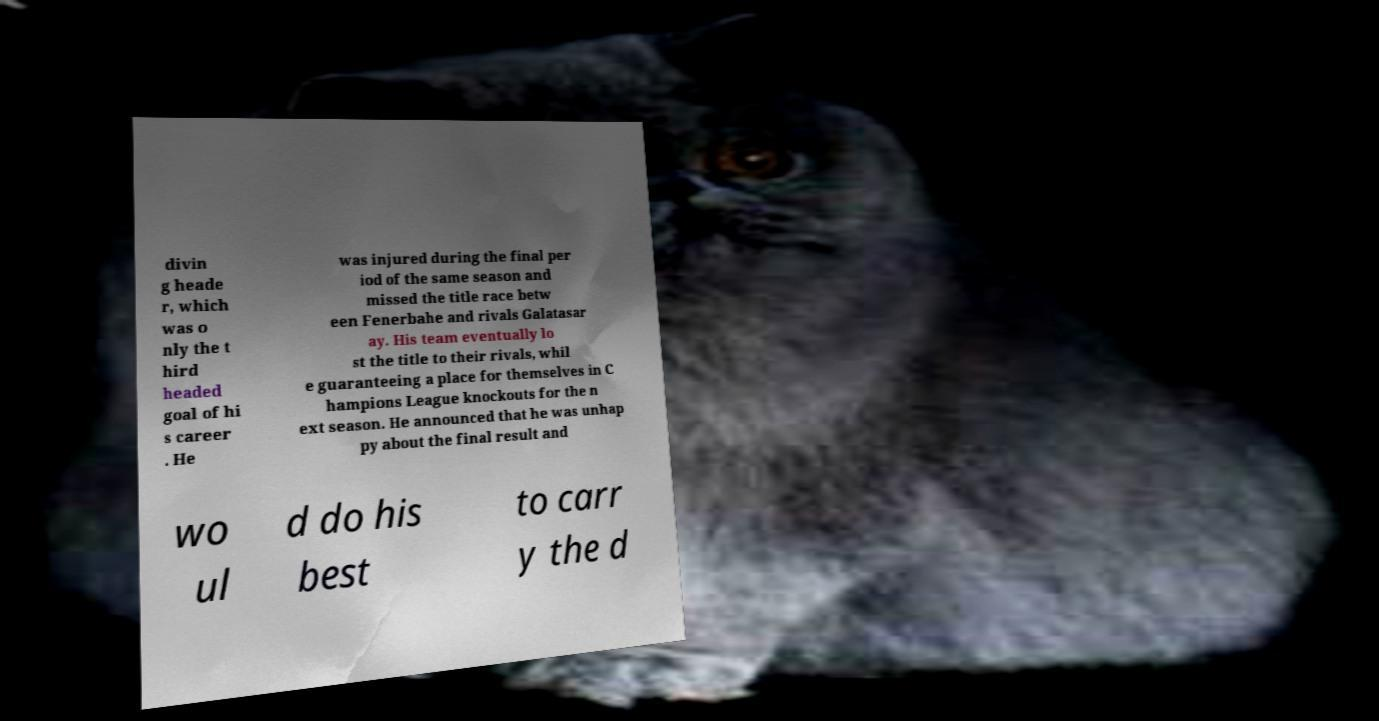What messages or text are displayed in this image? I need them in a readable, typed format. divin g heade r, which was o nly the t hird headed goal of hi s career . He was injured during the final per iod of the same season and missed the title race betw een Fenerbahe and rivals Galatasar ay. His team eventually lo st the title to their rivals, whil e guaranteeing a place for themselves in C hampions League knockouts for the n ext season. He announced that he was unhap py about the final result and wo ul d do his best to carr y the d 